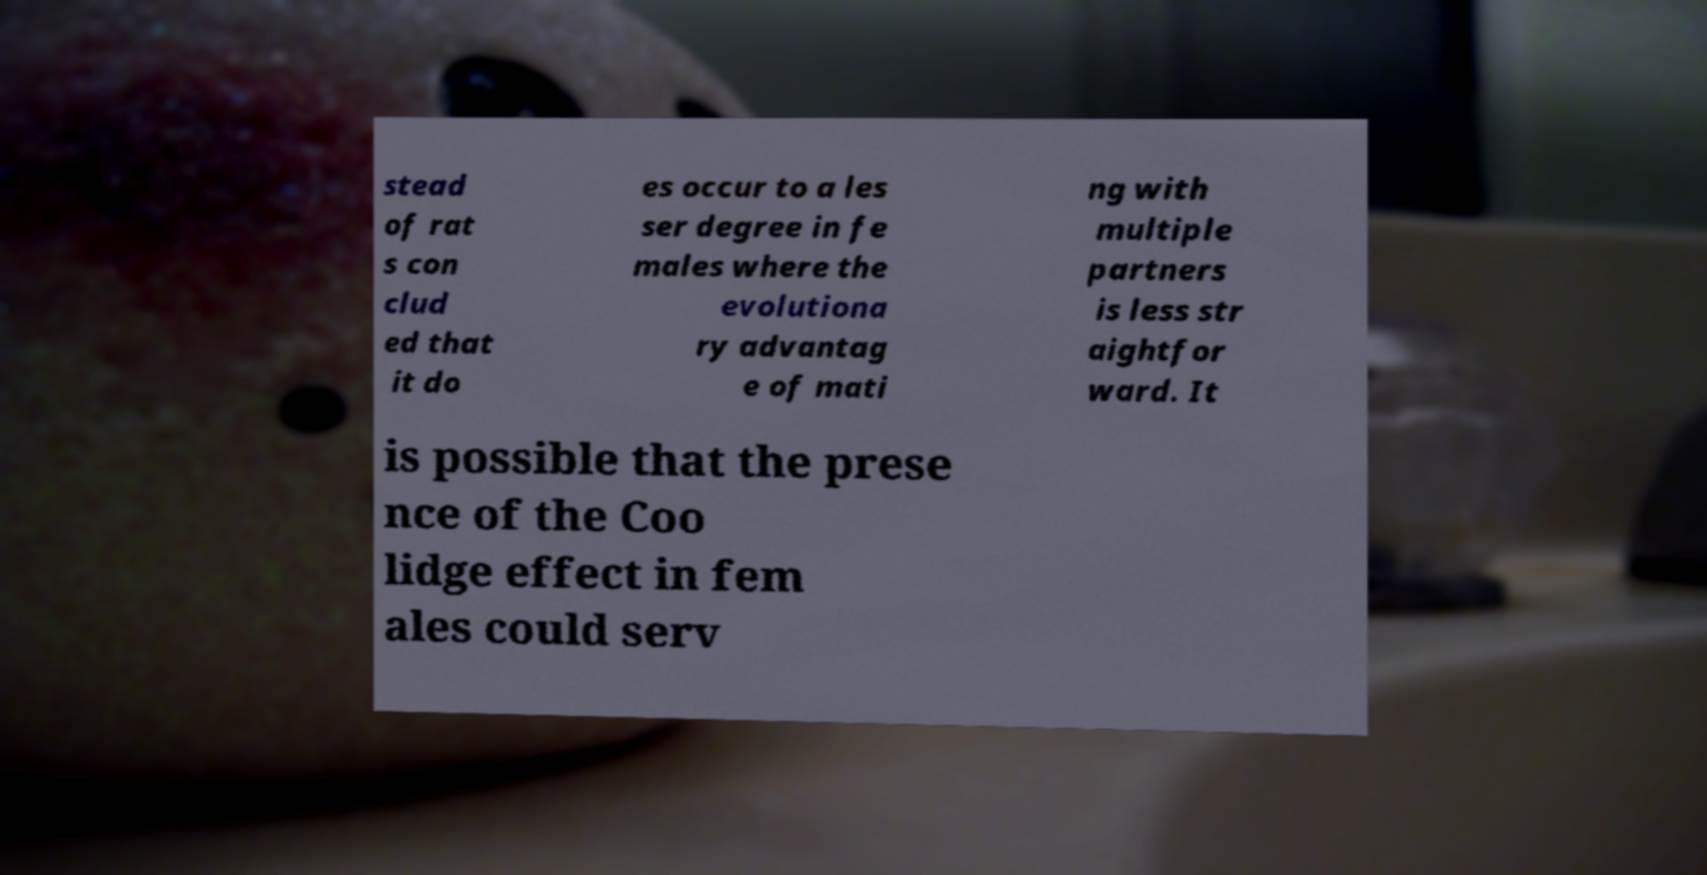Please read and relay the text visible in this image. What does it say? stead of rat s con clud ed that it do es occur to a les ser degree in fe males where the evolutiona ry advantag e of mati ng with multiple partners is less str aightfor ward. It is possible that the prese nce of the Coo lidge effect in fem ales could serv 